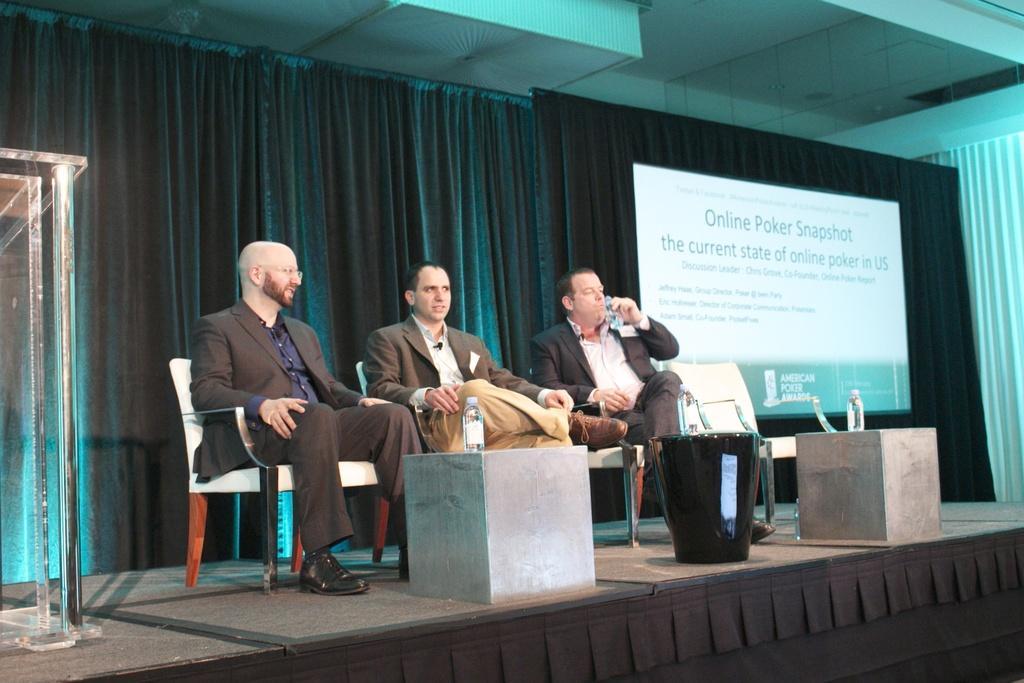Please provide a concise description of this image. In this image, we can see three persons wearing clothes and sitting on chairs. There is a stage at the bottom of the image. There is a banner in the middle of the image. There is a podium on the left side of the image. There are bottles on tables. 